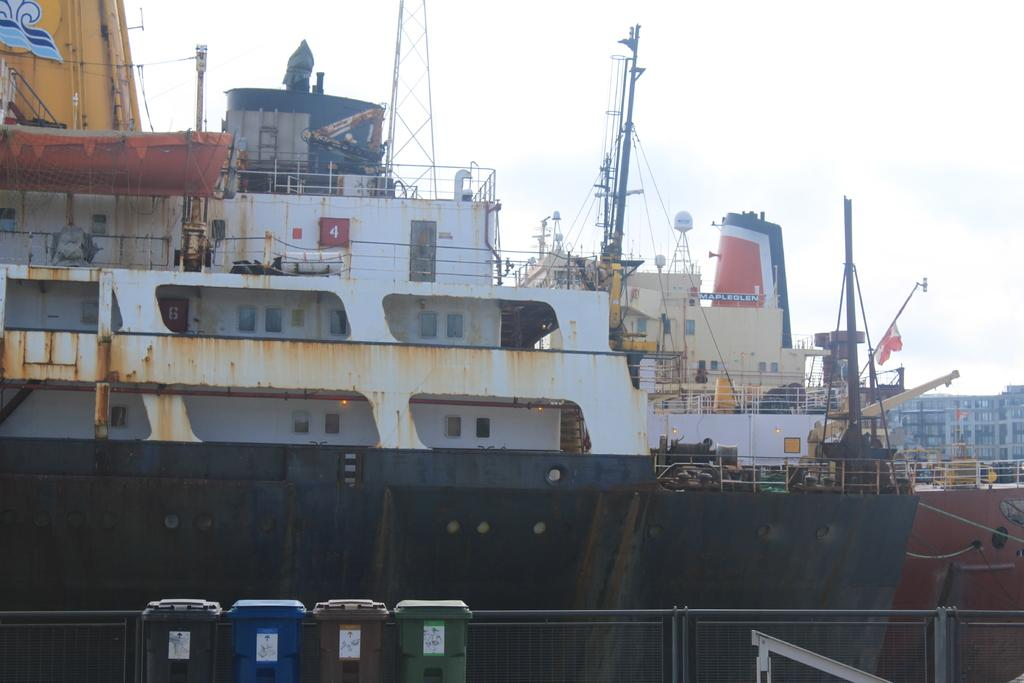<image>
Describe the image concisely. A very old rusty ship made by Maplegen 